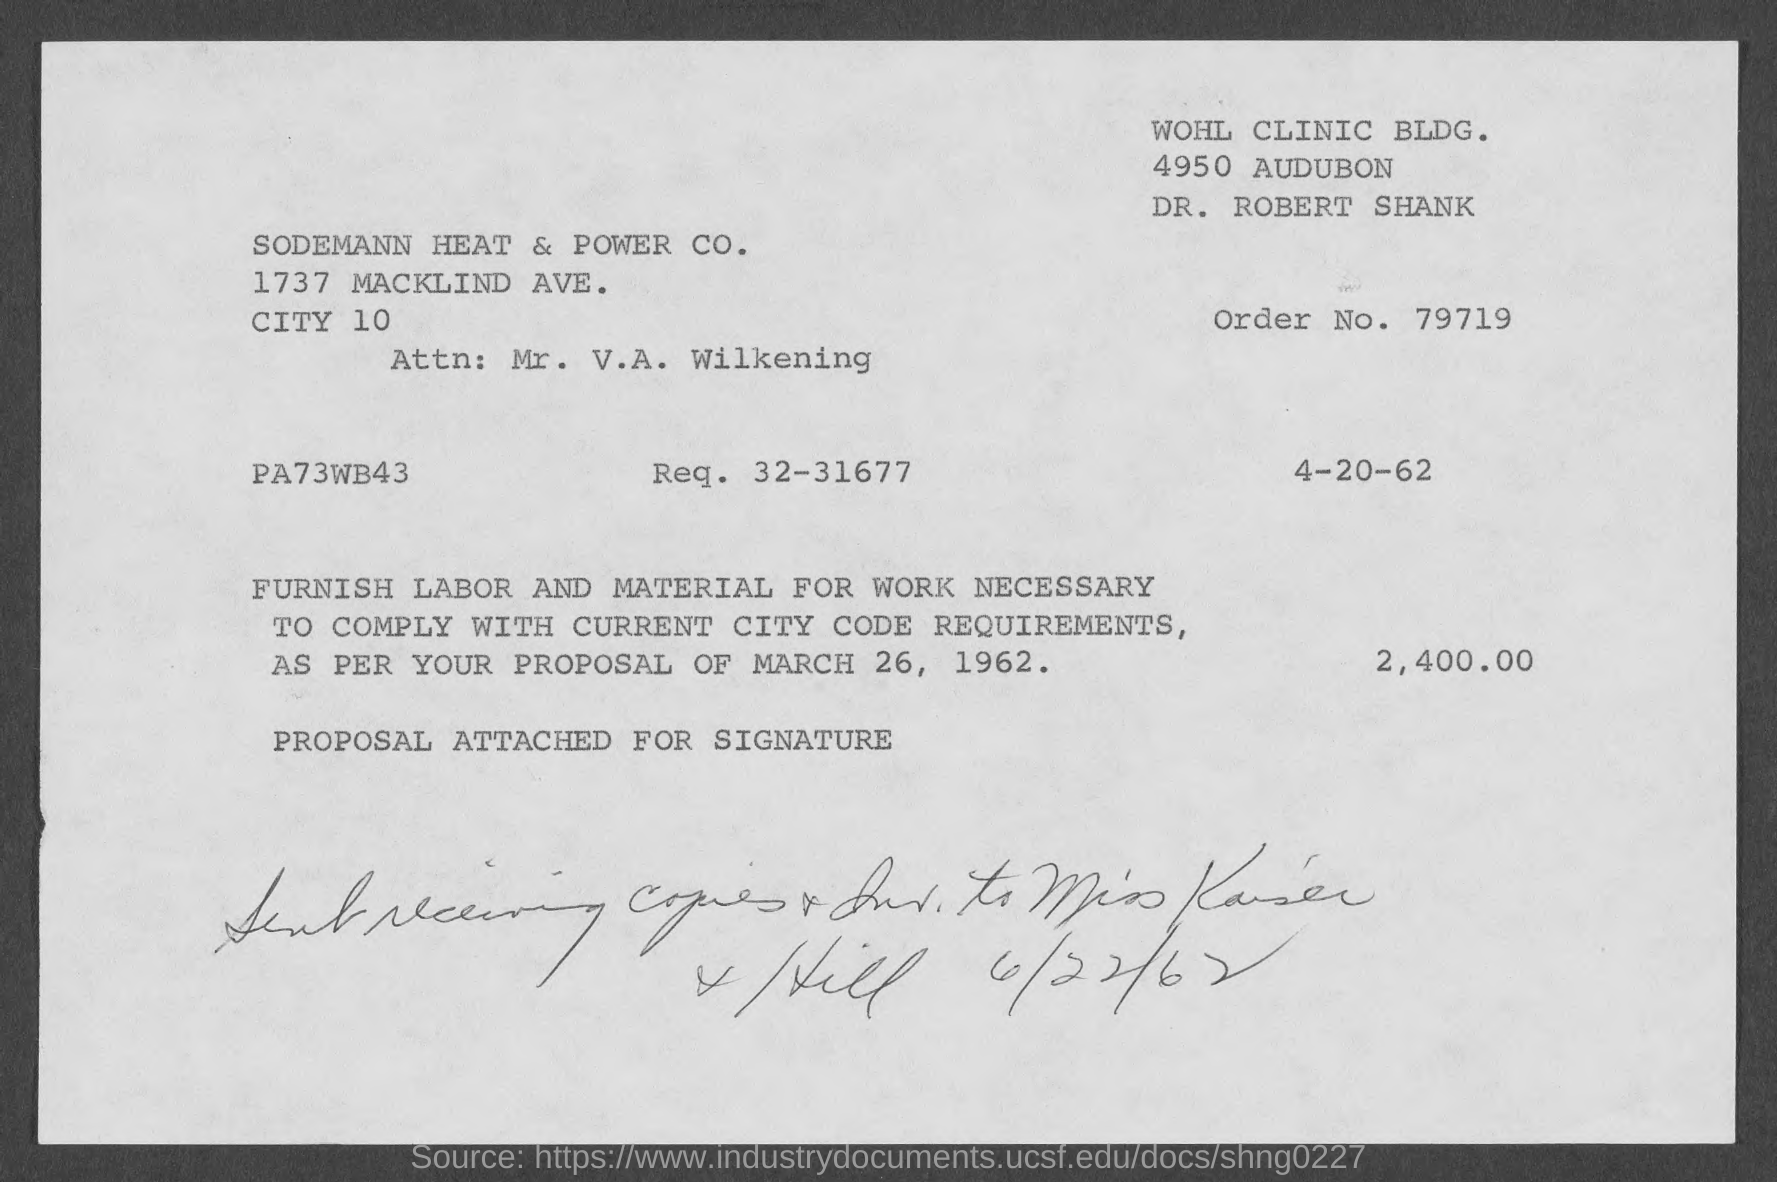List a handful of essential elements in this visual. The order number is 79719. 